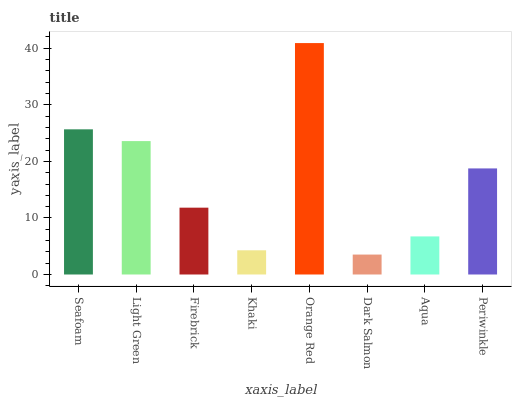Is Dark Salmon the minimum?
Answer yes or no. Yes. Is Orange Red the maximum?
Answer yes or no. Yes. Is Light Green the minimum?
Answer yes or no. No. Is Light Green the maximum?
Answer yes or no. No. Is Seafoam greater than Light Green?
Answer yes or no. Yes. Is Light Green less than Seafoam?
Answer yes or no. Yes. Is Light Green greater than Seafoam?
Answer yes or no. No. Is Seafoam less than Light Green?
Answer yes or no. No. Is Periwinkle the high median?
Answer yes or no. Yes. Is Firebrick the low median?
Answer yes or no. Yes. Is Seafoam the high median?
Answer yes or no. No. Is Khaki the low median?
Answer yes or no. No. 